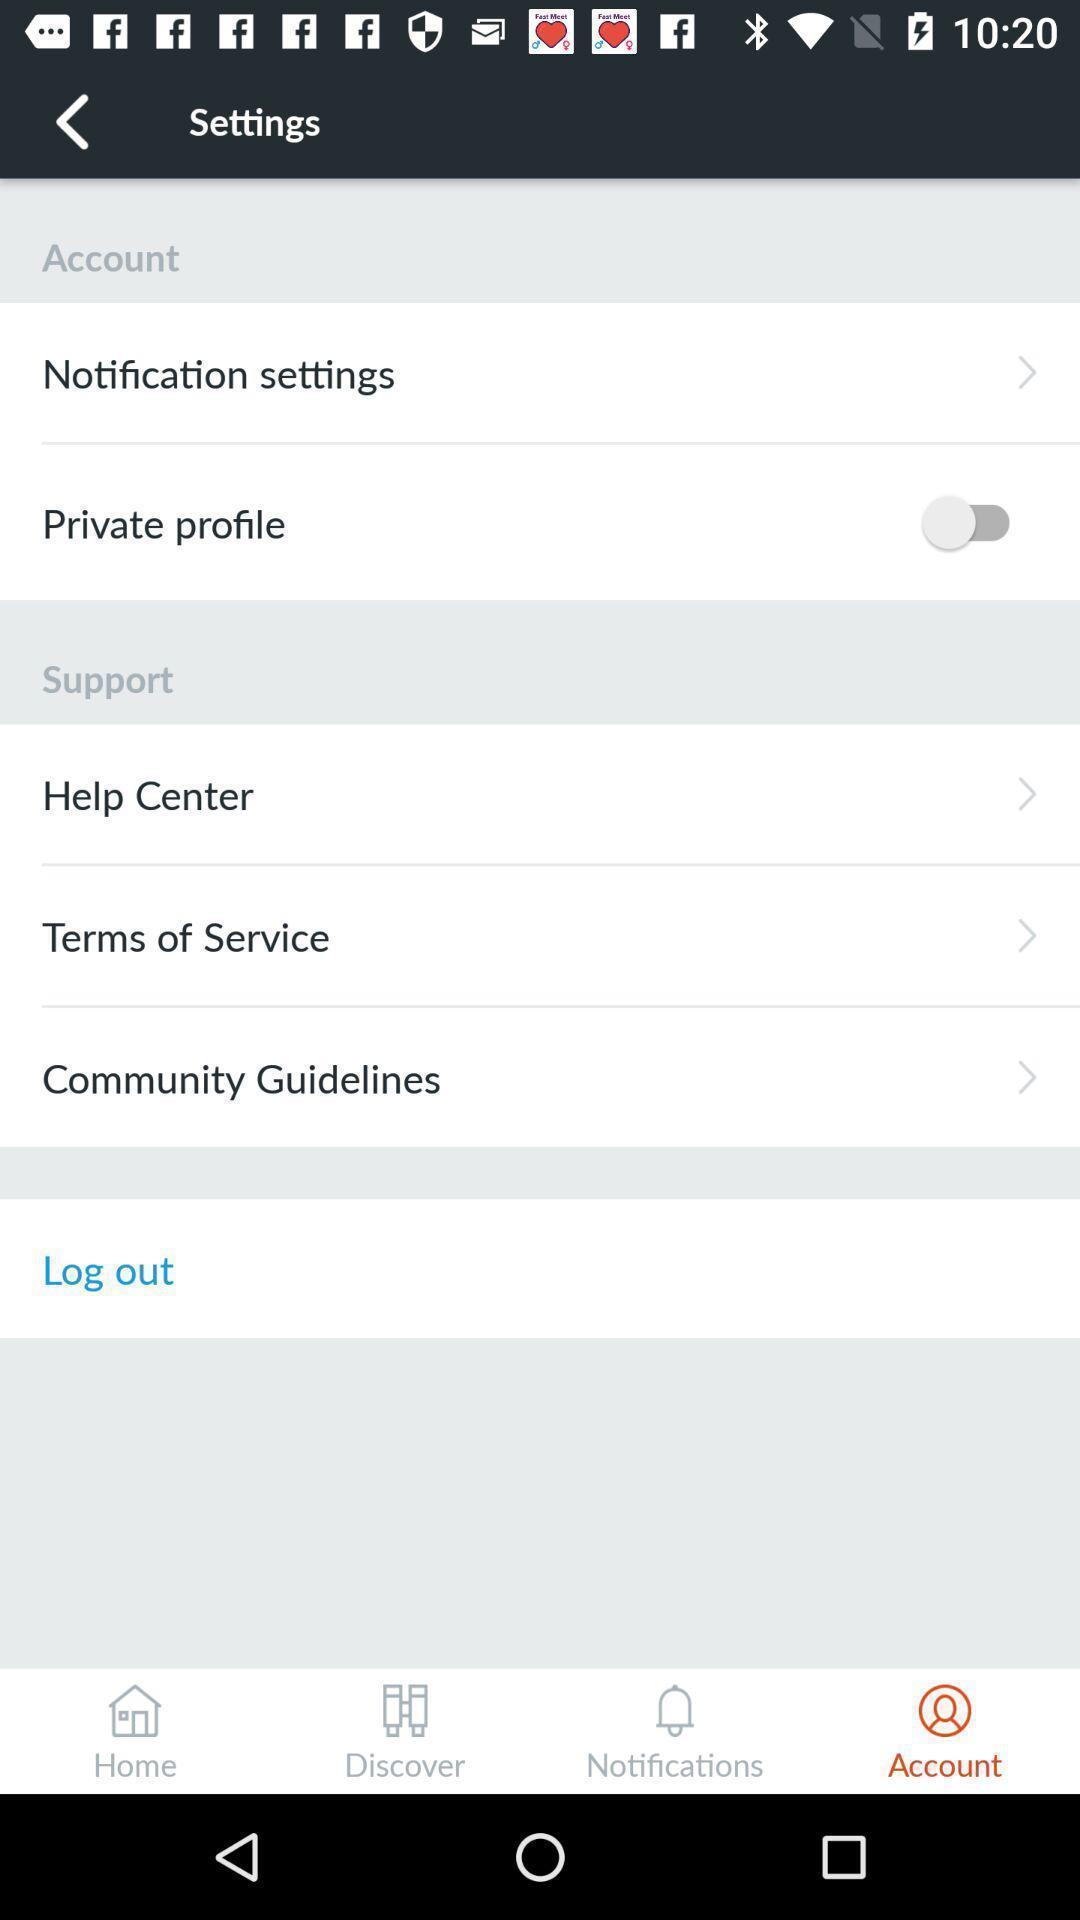Summarize the information in this screenshot. Setting page displaying the various options. 